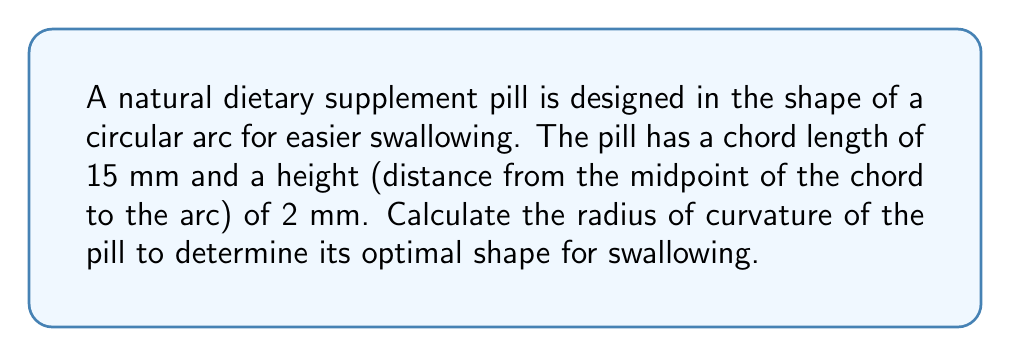Solve this math problem. To find the radius of curvature, we can use the formula for the radius of a circular segment:

$$R = \frac{h}{2} + \frac{c^2}{8h}$$

Where:
$R$ = radius of curvature
$h$ = height of the segment (distance from chord to arc)
$c$ = length of the chord

Given:
$h = 2$ mm
$c = 15$ mm

Step 1: Substitute the known values into the formula.
$$R = \frac{2}{2} + \frac{15^2}{8(2)}$$

Step 2: Simplify the equation.
$$R = 1 + \frac{225}{16}$$

Step 3: Perform the division in the fraction.
$$R = 1 + 14.0625$$

Step 4: Add the terms.
$$R = 15.0625$$

Therefore, the radius of curvature of the dietary supplement pill is approximately 15.0625 mm.
Answer: $15.0625$ mm 